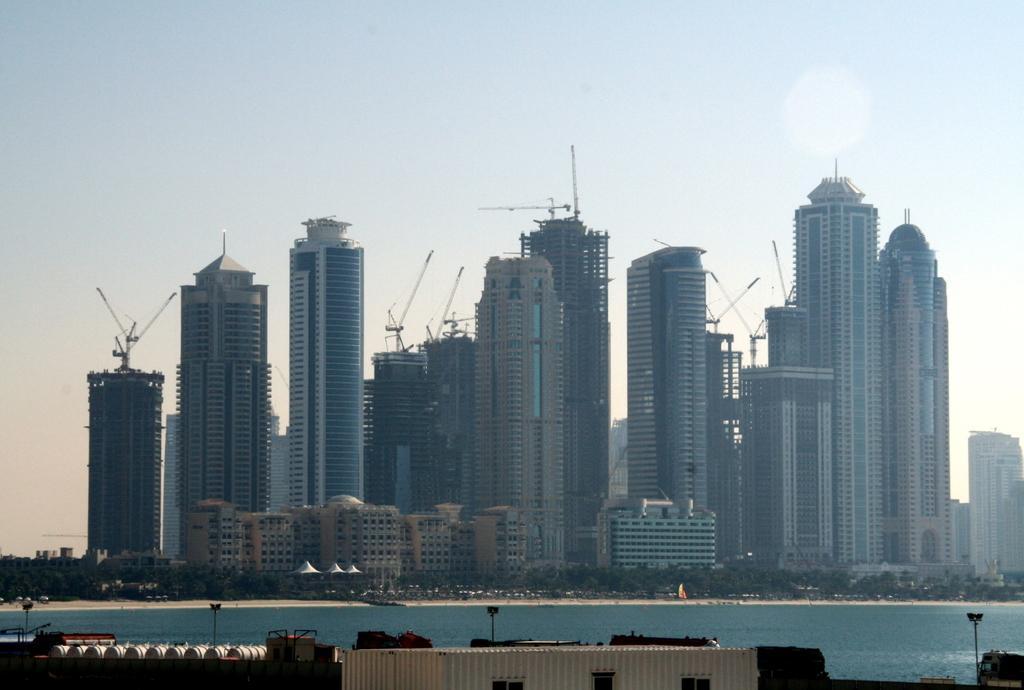Please provide a concise description of this image. In this image we can see many buildings and also trees and some cranes. At the top we can see the sky and at the bottom we can see the sea. Light poles are also visible in this image. 